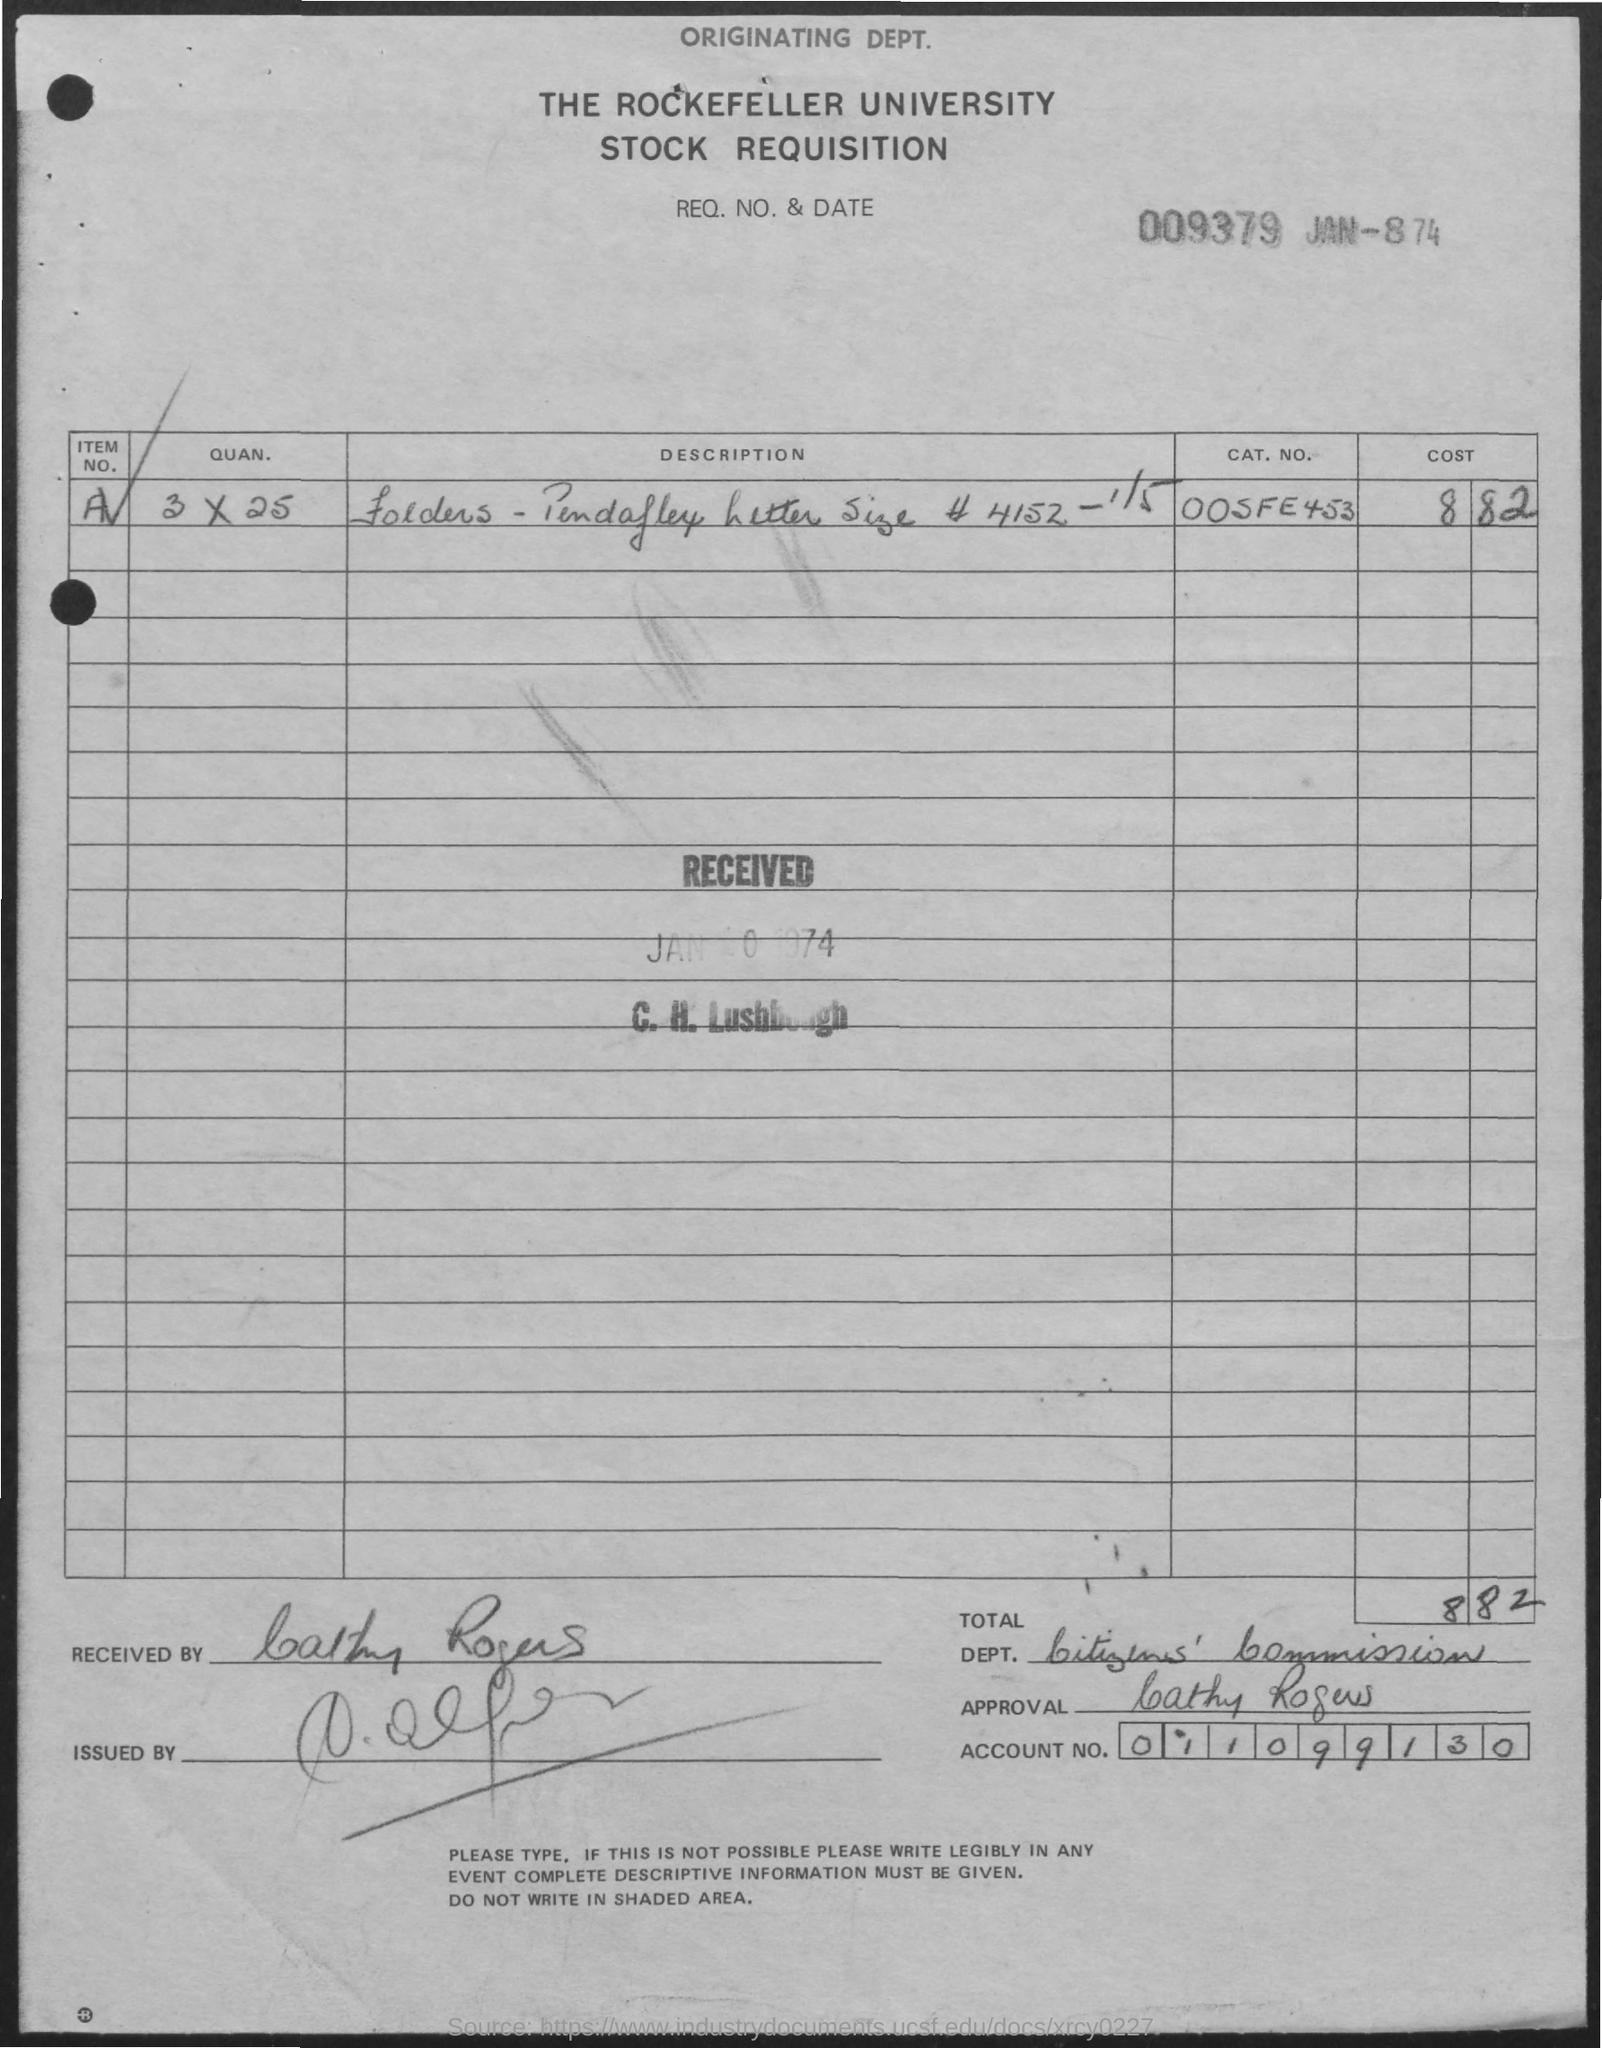Draw attention to some important aspects in this diagram. The document title is 'THE ROCKEFELLER UNIVERSITY STOCK REQUISITION.' The account number is 011099130... 